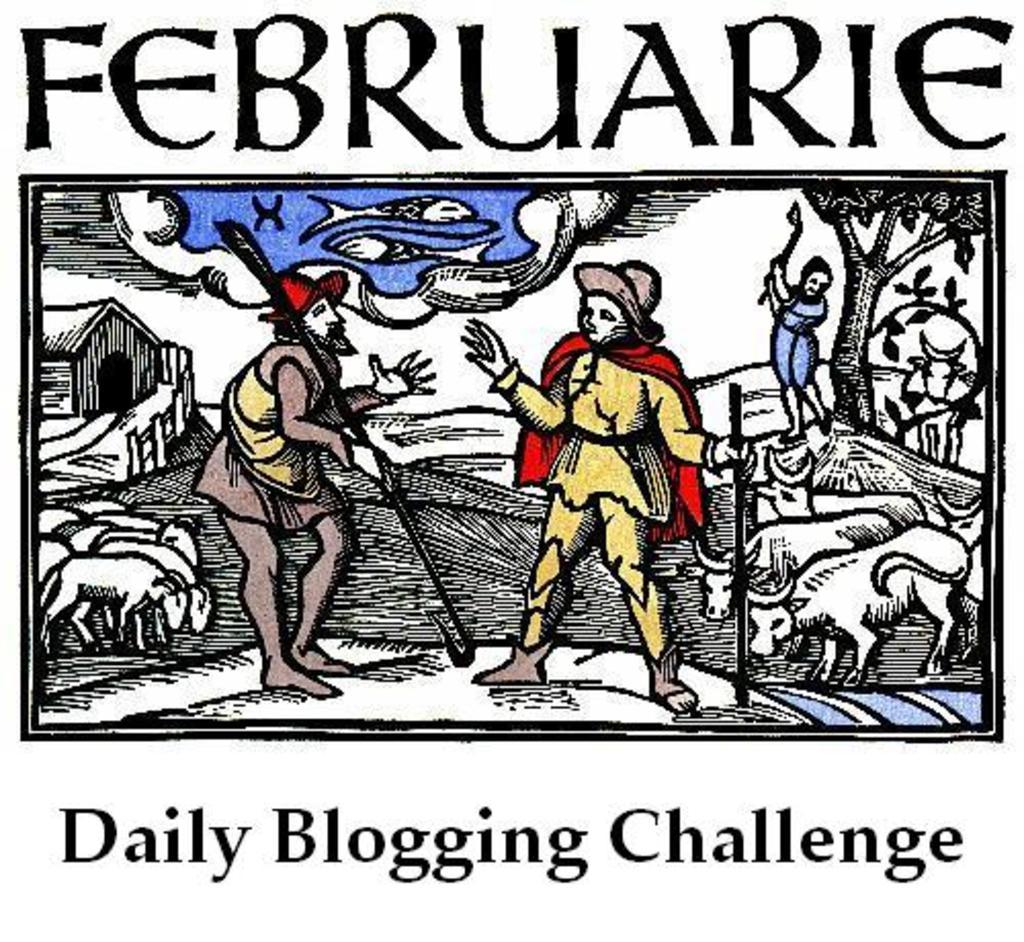What can be seen in the image? There are people standing in the image, and cattle are present as well. What might be the purpose of the text above and below the image? The text above and below the image could provide context, a title, or a caption for the scene. What type of feast is being held by the bears in the image? There are no bears present in the image, so it is not a feast involving bears cannot be observed. 